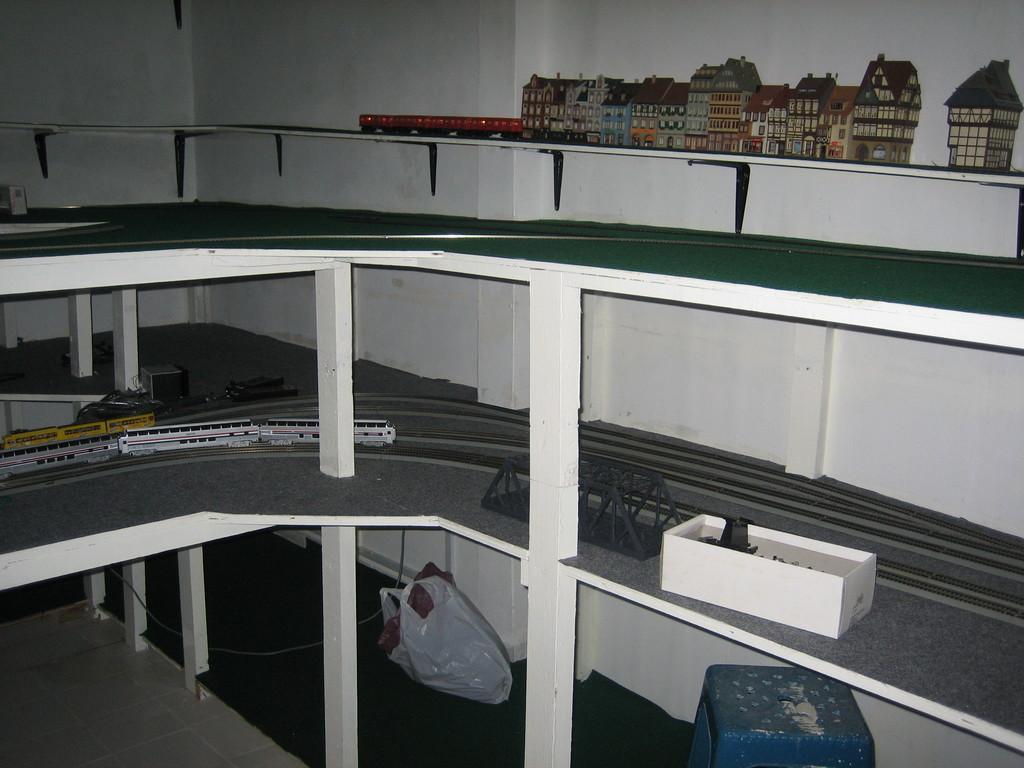Please provide a concise description of this image. In this image I can see at the top it looks like a miniature, there are buildings and a railway train tracks in the racks. At the bottom there is the white color cover. 